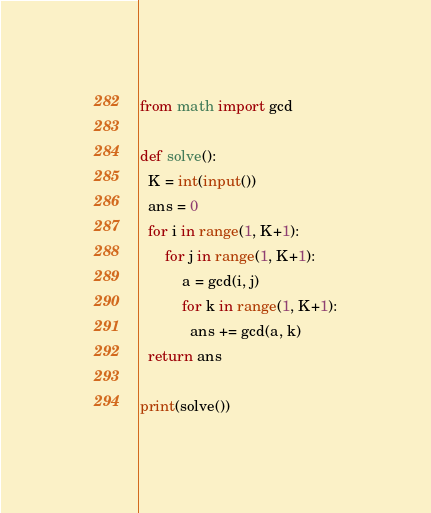<code> <loc_0><loc_0><loc_500><loc_500><_Python_>from math import gcd

def solve():
  K = int(input())
  ans = 0
  for i in range(1, K+1):
      for j in range(1, K+1):
          a = gcd(i, j)
          for k in range(1, K+1):
            ans += gcd(a, k)
  return ans
                
print(solve())</code> 